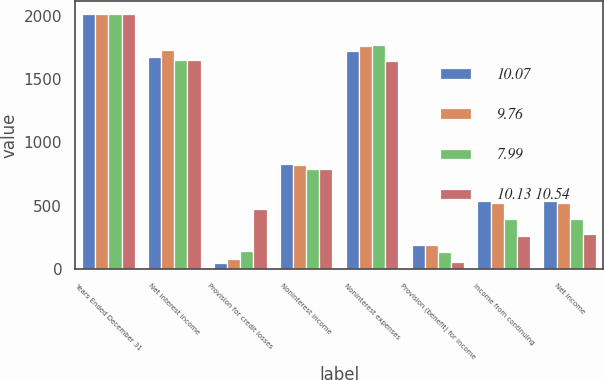Convert chart to OTSL. <chart><loc_0><loc_0><loc_500><loc_500><stacked_bar_chart><ecel><fcel>Years Ended December 31<fcel>Net interest income<fcel>Provision for credit losses<fcel>Noninterest income<fcel>Noninterest expenses<fcel>Provision (benefit) for income<fcel>Income from continuing<fcel>Net income<nl><fcel>10.07<fcel>2013<fcel>1672<fcel>46<fcel>826<fcel>1722<fcel>189<fcel>541<fcel>541<nl><fcel>9.76<fcel>2012<fcel>1728<fcel>79<fcel>818<fcel>1757<fcel>189<fcel>521<fcel>521<nl><fcel>7.99<fcel>2011<fcel>1653<fcel>144<fcel>792<fcel>1771<fcel>137<fcel>393<fcel>393<nl><fcel>10.13 10.54<fcel>2010<fcel>1646<fcel>478<fcel>789<fcel>1642<fcel>55<fcel>260<fcel>277<nl></chart> 